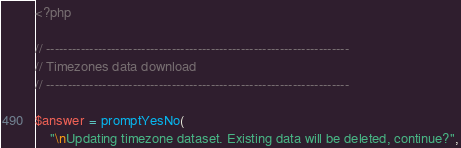<code> <loc_0><loc_0><loc_500><loc_500><_PHP_><?php

// ----------------------------------------------------------------------
// Timezones data download
// ----------------------------------------------------------------------

$answer = promptYesNo(
    "\nUpdating timezone dataset. Existing data will be deleted, continue?",</code> 